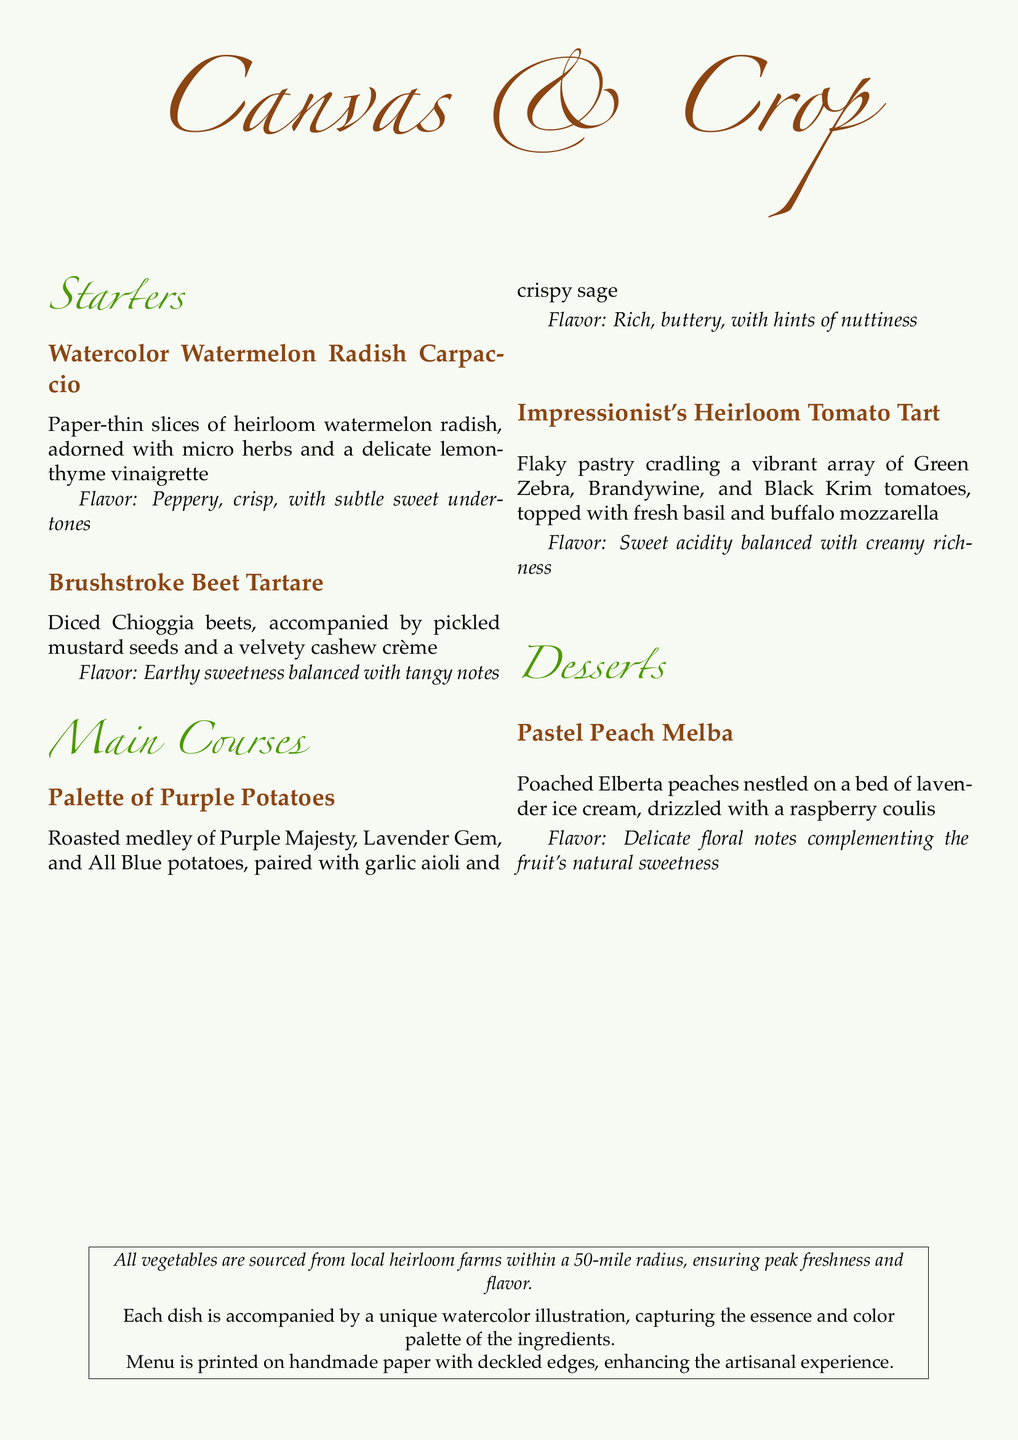What is the first dish listed under Starters? The first dish listed under Starters is the "Watercolor Watermelon Radish Carpaccio."
Answer: Watercolor Watermelon Radish Carpaccio How many main courses are on the menu? The menu includes two main courses.
Answer: 2 What unique ingredient accompanies the Brushstroke Beet Tartare? The unique ingredient that accompanies the Brushstroke Beet Tartare is pickled mustard seeds.
Answer: Pickled mustard seeds What type of ice cream is served with the Pastel Peach Melba? The type of ice cream served with the Pastel Peach Melba is lavender ice cream.
Answer: Lavender ice cream What vegetables are mentioned in the Palette of Purple Potatoes dish? The Palette of Purple Potatoes dish mentions Purple Majesty, Lavender Gem, and All Blue potatoes.
Answer: Purple Majesty, Lavender Gem, All Blue What is the color palette used in the illustrations? The illustrations capture the essence and color palette of the ingredients.
Answer: Essence and color palette of the ingredients How is the menu printed? The menu is printed on handmade paper with deckled edges.
Answer: Handmade paper with deckled edges What is the flavor profile of the Impressionist's Heirloom Tomato Tart? The flavor profile of the Impressionist's Heirloom Tomato Tart is sweet acidity balanced with creamy richness.
Answer: Sweet acidity balanced with creamy richness 